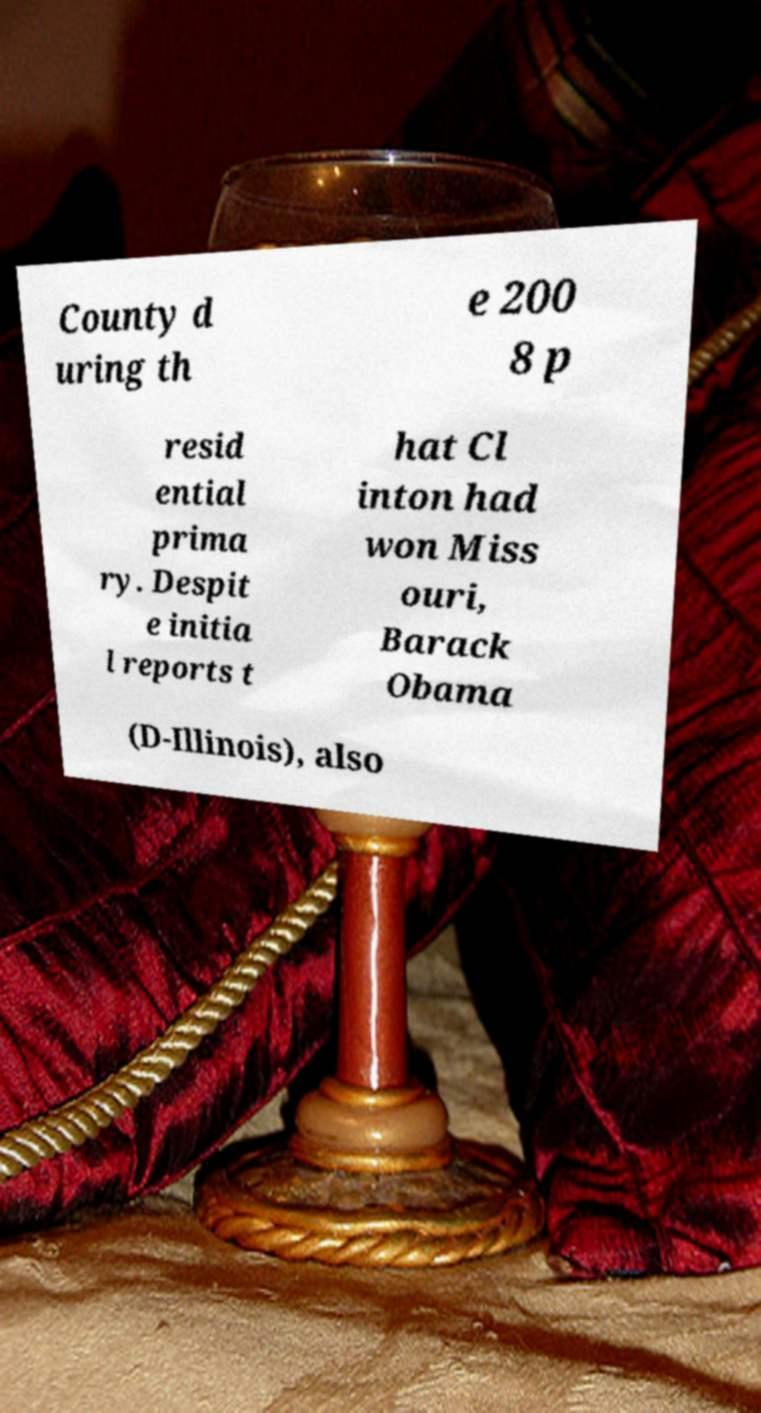I need the written content from this picture converted into text. Can you do that? County d uring th e 200 8 p resid ential prima ry. Despit e initia l reports t hat Cl inton had won Miss ouri, Barack Obama (D-Illinois), also 